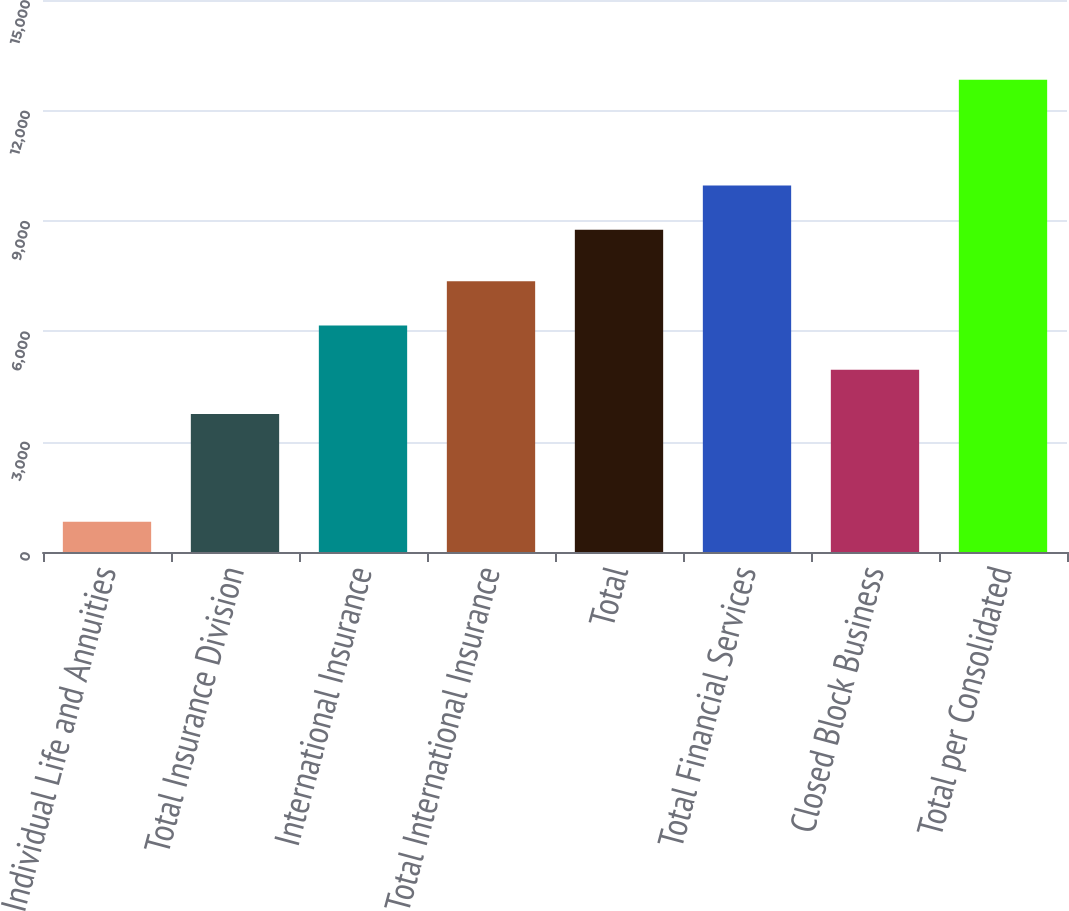<chart> <loc_0><loc_0><loc_500><loc_500><bar_chart><fcel>Individual Life and Annuities<fcel>Total Insurance Division<fcel>International Insurance<fcel>Total International Insurance<fcel>Total<fcel>Total Financial Services<fcel>Closed Block Business<fcel>Total per Consolidated<nl><fcel>822<fcel>3752<fcel>6154.8<fcel>7356.2<fcel>8757<fcel>9958.4<fcel>4953.4<fcel>12836<nl></chart> 